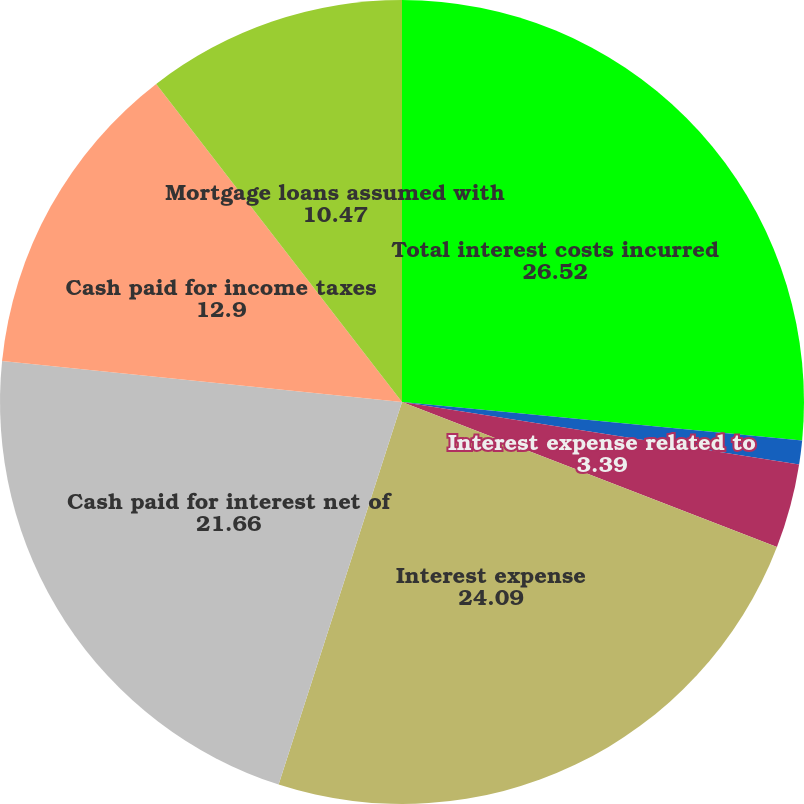<chart> <loc_0><loc_0><loc_500><loc_500><pie_chart><fcel>Total interest costs incurred<fcel>Interest capitalized<fcel>Interest expense related to<fcel>Interest expense<fcel>Cash paid for interest net of<fcel>Cash paid for income taxes<fcel>Mortgage loans assumed with<nl><fcel>26.52%<fcel>0.96%<fcel>3.39%<fcel>24.09%<fcel>21.66%<fcel>12.9%<fcel>10.47%<nl></chart> 